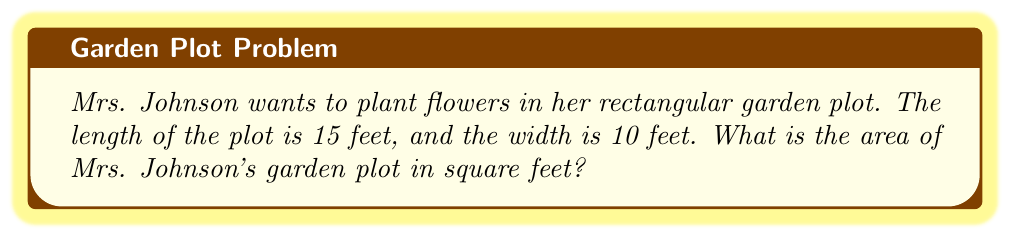Solve this math problem. To find the area of a rectangular garden plot, we need to multiply its length by its width. Let's break this down step-by-step:

1. We know the length of the plot: 15 feet
2. We know the width of the plot: 10 feet
3. The formula for the area of a rectangle is:

   $$ \text{Area} = \text{length} \times \text{width} $$

4. Let's substitute our values into the formula:

   $$ \text{Area} = 15 \text{ feet} \times 10 \text{ feet} $$

5. Now, let's multiply:

   $$ \text{Area} = 150 \text{ square feet} $$

Therefore, the area of Mrs. Johnson's garden plot is 150 square feet.

[asy]
unitsize(0.5cm);
draw((0,0)--(15,0)--(15,10)--(0,10)--cycle);
label("15 feet", (7.5,0), S);
label("10 feet", (15,5), E);
label("Garden Plot", (7.5,5), N);
[/asy]
Answer: 150 square feet 